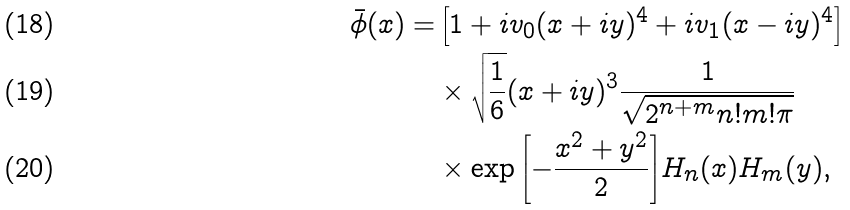<formula> <loc_0><loc_0><loc_500><loc_500>\bar { \phi } ( { x } ) = & \left [ 1 + i v _ { 0 } ( x + i y ) ^ { 4 } + i v _ { 1 } ( x - i y ) ^ { 4 } \right ] \\ & \times \sqrt { \frac { 1 } { 6 } } ( x + i y ) ^ { 3 } \frac { 1 } { \sqrt { 2 ^ { n + m } n ! m ! \pi } } \\ & \times \exp { \left [ - \frac { x ^ { 2 } + y ^ { 2 } } { 2 } \right ] } H _ { n } ( x ) H _ { m } ( y ) ,</formula> 